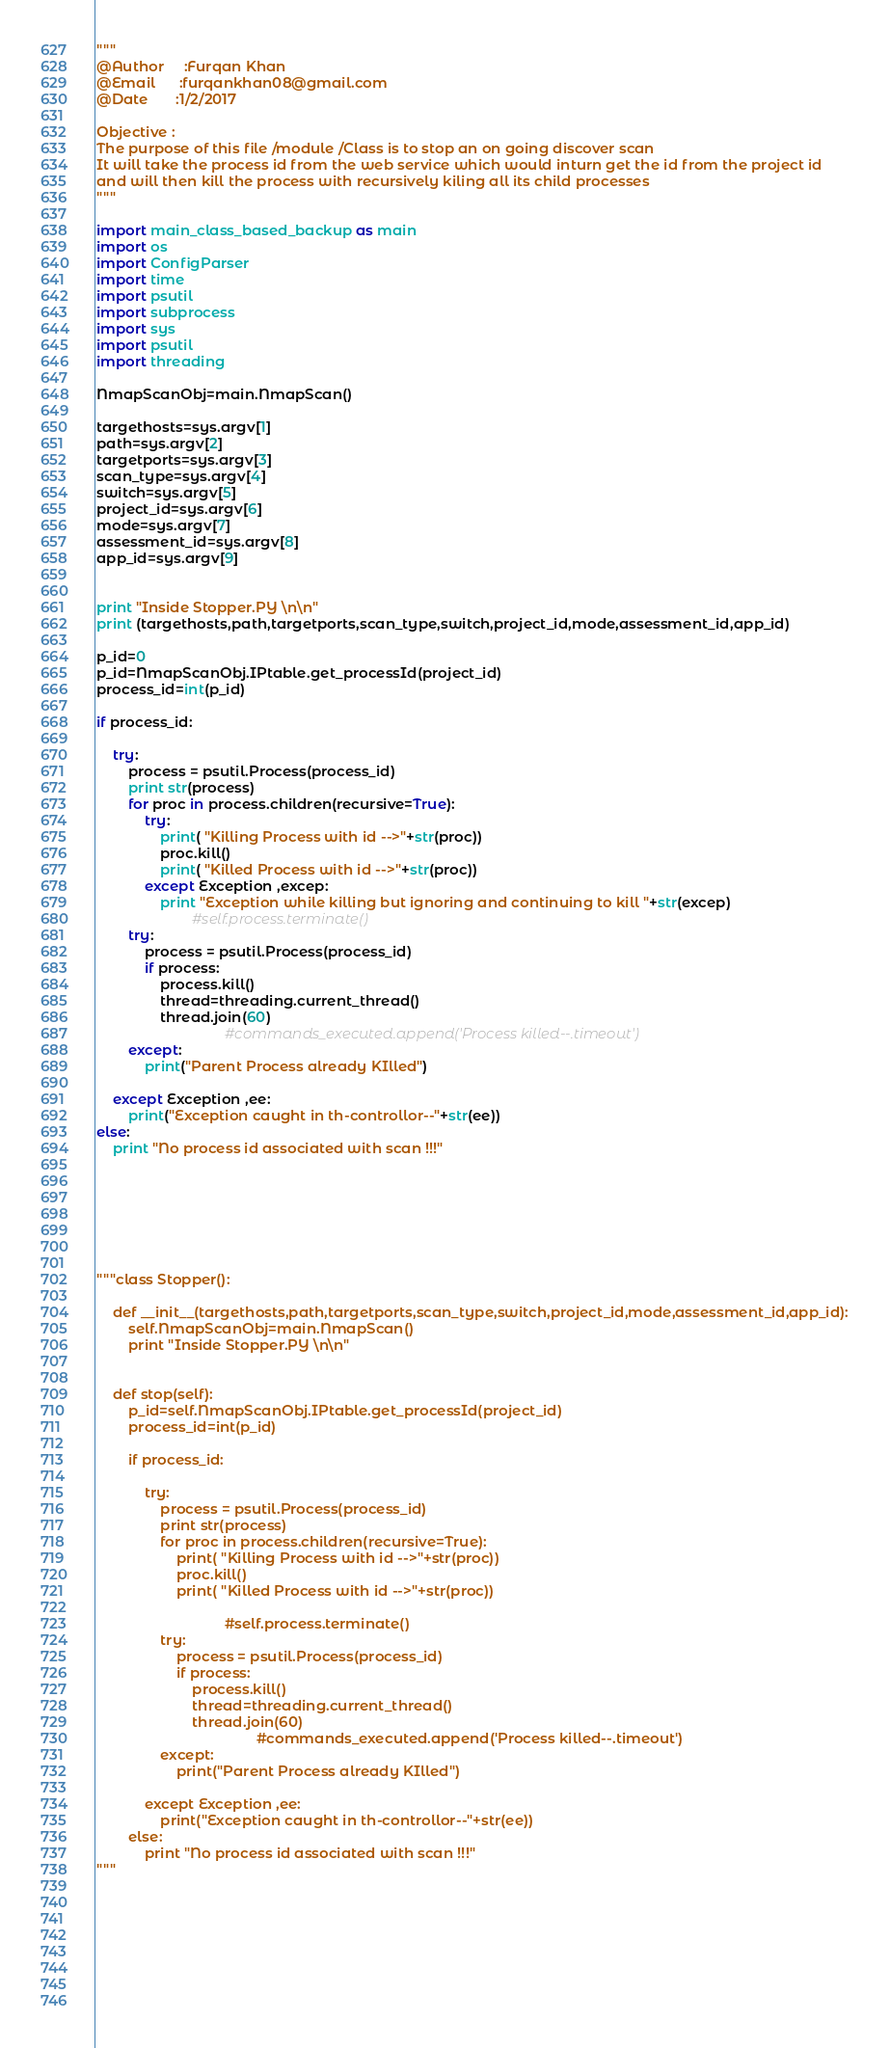<code> <loc_0><loc_0><loc_500><loc_500><_Python_>"""
@Author		:Furqan Khan
@Email		:furqankhan08@gmail.com
@Date 		:1/2/2017

Objective :
The purpose of this file /module /Class is to stop an on going discover scan
It will take the process id from the web service which would inturn get the id from the project id
and will then kill the process with recursively kiling all its child processes
"""

import main_class_based_backup as main
import os
import ConfigParser
import time
import psutil
import subprocess
import sys
import psutil
import threading

NmapScanObj=main.NmapScan()

targethosts=sys.argv[1]
path=sys.argv[2]
targetports=sys.argv[3]
scan_type=sys.argv[4]
switch=sys.argv[5]
project_id=sys.argv[6]
mode=sys.argv[7]
assessment_id=sys.argv[8]
app_id=sys.argv[9]


print "Inside Stopper.PY \n\n"
print (targethosts,path,targetports,scan_type,switch,project_id,mode,assessment_id,app_id)

p_id=0
p_id=NmapScanObj.IPtable.get_processId(project_id)
process_id=int(p_id)

if process_id:

	try:
		process = psutil.Process(process_id)
		print str(process)
		for proc in process.children(recursive=True):
			try:
				print( "Killing Process with id -->"+str(proc))
				proc.kill()
				print( "Killed Process with id -->"+str(proc))
			except Exception ,excep:
				print "Exception while killing but ignoring and continuing to kill "+str(excep)
						#self.process.terminate()
		try:
			process = psutil.Process(process_id)
			if process:
				process.kill()
				thread=threading.current_thread()
				thread.join(60)
								#commands_executed.append('Process killed--.timeout')
		except:
			print("Parent Process already KIlled")
	    
	except Exception ,ee:
		print("Exception caught in th-controllor--"+str(ee))
else:
	print "No process id associated with scan !!!"







"""class Stopper():

	def __init__(targethosts,path,targetports,scan_type,switch,project_id,mode,assessment_id,app_id):
		self.NmapScanObj=main.NmapScan()		
		print "Inside Stopper.PY \n\n"


	def stop(self):
		p_id=self.NmapScanObj.IPtable.get_processId(project_id)
		process_id=int(p_id)

		if process_id:

			try:
				process = psutil.Process(process_id)
				print str(process)
				for proc in process.children(recursive=True):
					print( "Killing Process with id -->"+str(proc))
					proc.kill()
					print( "Killed Process with id -->"+str(proc))
						
								#self.process.terminate()
				try:
					process = psutil.Process(process_id)
					if process:
						process.kill()
						thread=threading.current_thread()
						thread.join(60)
										#commands_executed.append('Process killed--.timeout')
				except:
					print("Parent Process already KIlled")
			
			except Exception ,ee:
				print("Exception caught in th-controllor--"+str(ee))
		else:
			print "No process id associated with scan !!!"
"""







		

</code> 